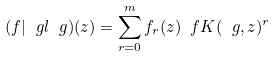Convert formula to latex. <formula><loc_0><loc_0><loc_500><loc_500>( f | _ { \ } g l \ g ) ( z ) = \sum ^ { m } _ { r = 0 } f _ { r } ( z ) \ f K ( \ g , z ) ^ { r }</formula> 